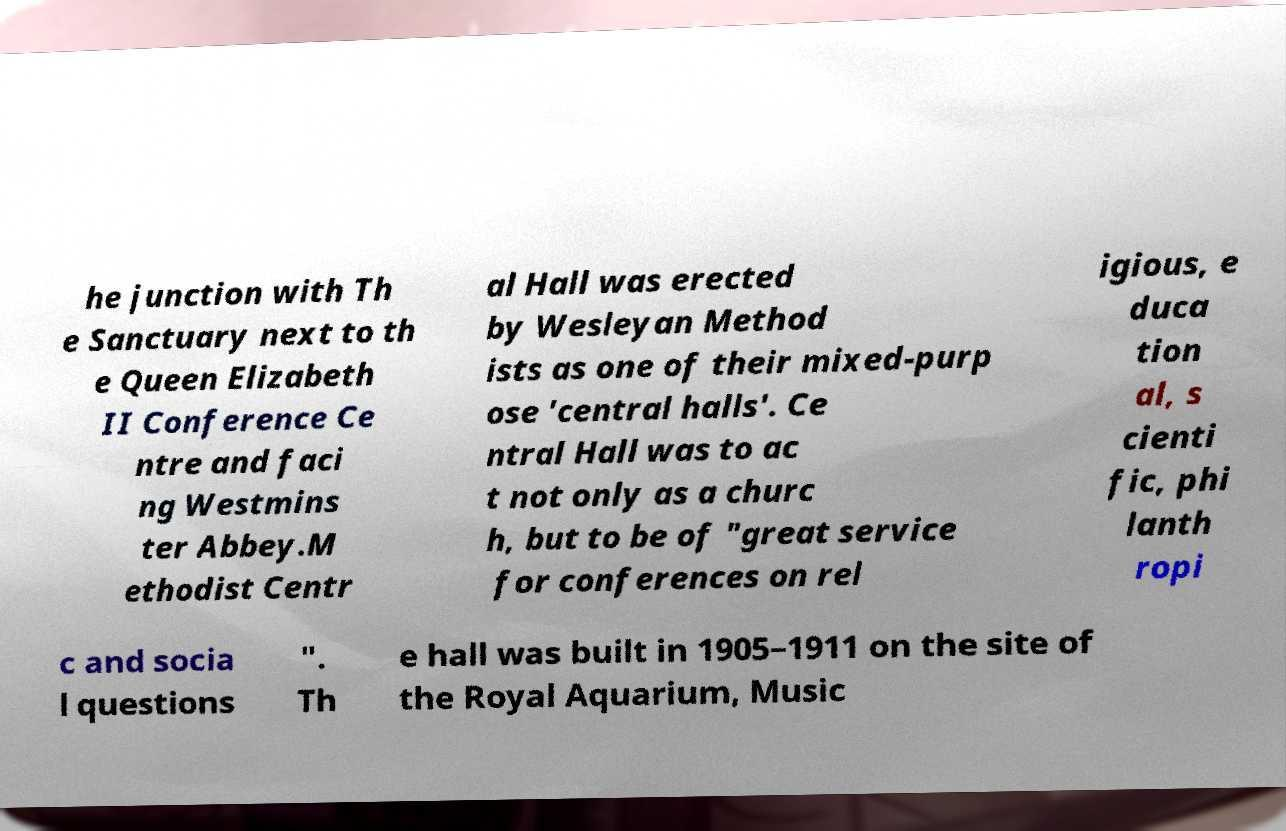Could you extract and type out the text from this image? he junction with Th e Sanctuary next to th e Queen Elizabeth II Conference Ce ntre and faci ng Westmins ter Abbey.M ethodist Centr al Hall was erected by Wesleyan Method ists as one of their mixed-purp ose 'central halls'. Ce ntral Hall was to ac t not only as a churc h, but to be of "great service for conferences on rel igious, e duca tion al, s cienti fic, phi lanth ropi c and socia l questions ". Th e hall was built in 1905–1911 on the site of the Royal Aquarium, Music 